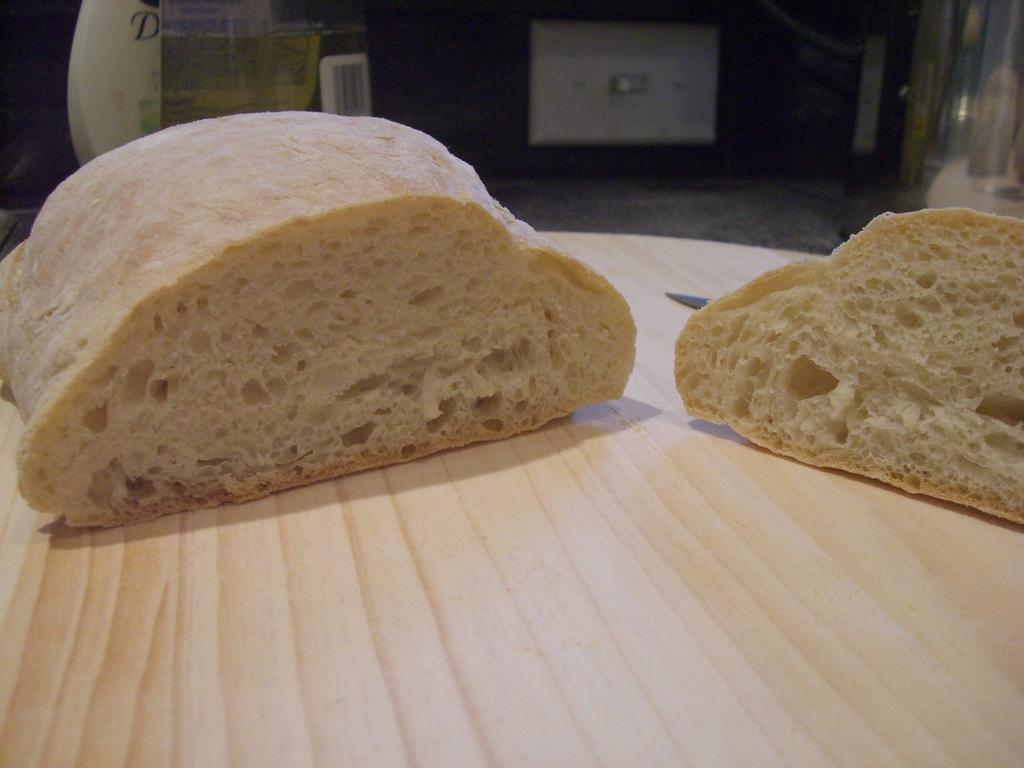What is the focus of the image? The image is a zoomed-in view. What can be seen in the foreground of the image? There are food items in the foreground of the image. What is the surface on which the food items are placed? The food items are placed on a wooden table. What else can be observed in the image? There are objects visible in the background of the image. How does the cabbage in the image affect the stomach of the person eating it? There is no cabbage present in the image, so it cannot be determined how it would affect the stomach of the person eating it. 